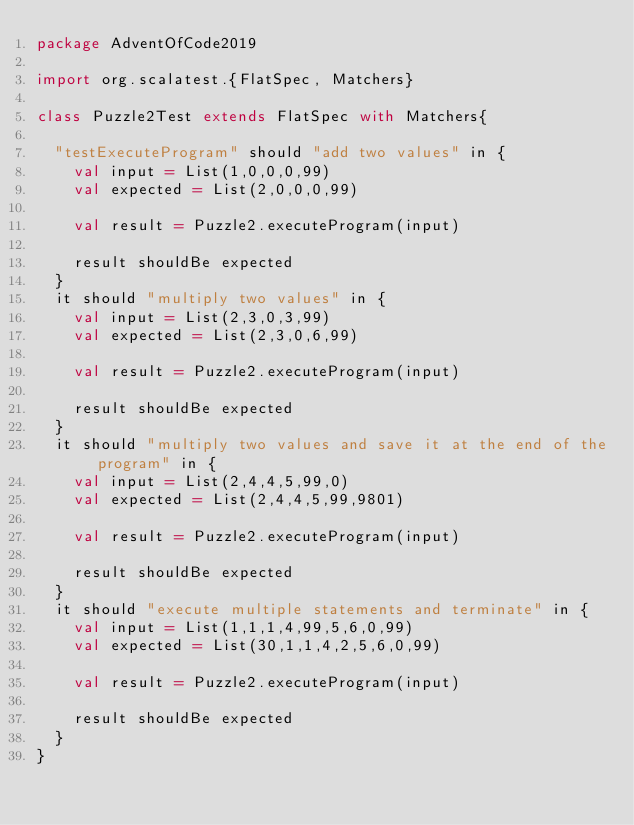Convert code to text. <code><loc_0><loc_0><loc_500><loc_500><_Scala_>package AdventOfCode2019

import org.scalatest.{FlatSpec, Matchers}

class Puzzle2Test extends FlatSpec with Matchers{

  "testExecuteProgram" should "add two values" in {
    val input = List(1,0,0,0,99)
    val expected = List(2,0,0,0,99)

    val result = Puzzle2.executeProgram(input)

    result shouldBe expected
  }
  it should "multiply two values" in {
    val input = List(2,3,0,3,99)
    val expected = List(2,3,0,6,99)

    val result = Puzzle2.executeProgram(input)

    result shouldBe expected
  }
  it should "multiply two values and save it at the end of the program" in {
    val input = List(2,4,4,5,99,0)
    val expected = List(2,4,4,5,99,9801)

    val result = Puzzle2.executeProgram(input)

    result shouldBe expected
  }
  it should "execute multiple statements and terminate" in {
    val input = List(1,1,1,4,99,5,6,0,99)
    val expected = List(30,1,1,4,2,5,6,0,99)

    val result = Puzzle2.executeProgram(input)

    result shouldBe expected
  }
}
</code> 